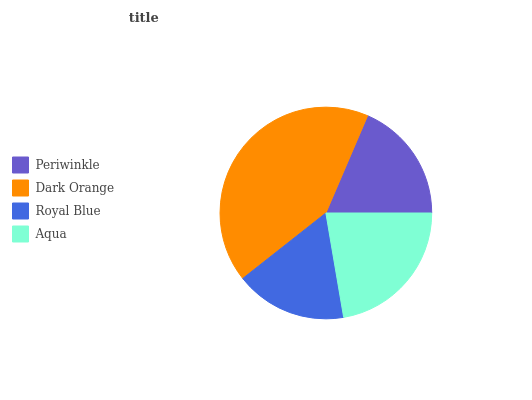Is Royal Blue the minimum?
Answer yes or no. Yes. Is Dark Orange the maximum?
Answer yes or no. Yes. Is Dark Orange the minimum?
Answer yes or no. No. Is Royal Blue the maximum?
Answer yes or no. No. Is Dark Orange greater than Royal Blue?
Answer yes or no. Yes. Is Royal Blue less than Dark Orange?
Answer yes or no. Yes. Is Royal Blue greater than Dark Orange?
Answer yes or no. No. Is Dark Orange less than Royal Blue?
Answer yes or no. No. Is Aqua the high median?
Answer yes or no. Yes. Is Periwinkle the low median?
Answer yes or no. Yes. Is Dark Orange the high median?
Answer yes or no. No. Is Dark Orange the low median?
Answer yes or no. No. 